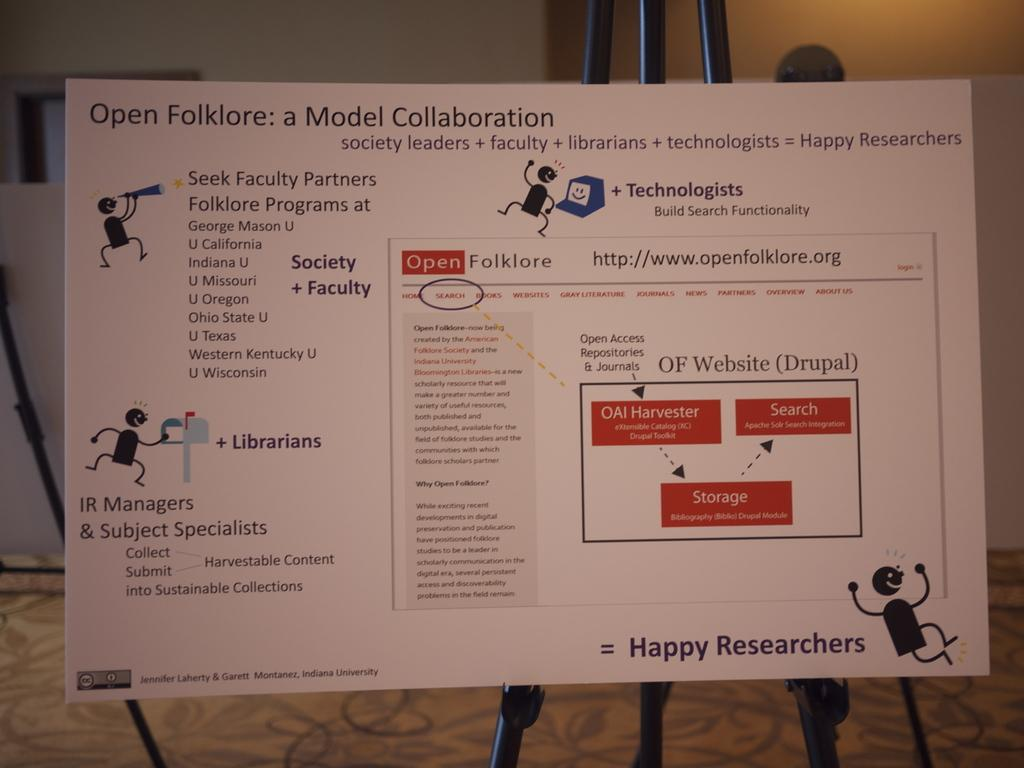<image>
Describe the image concisely. A sign is on a stand that says Happy Researchers. 